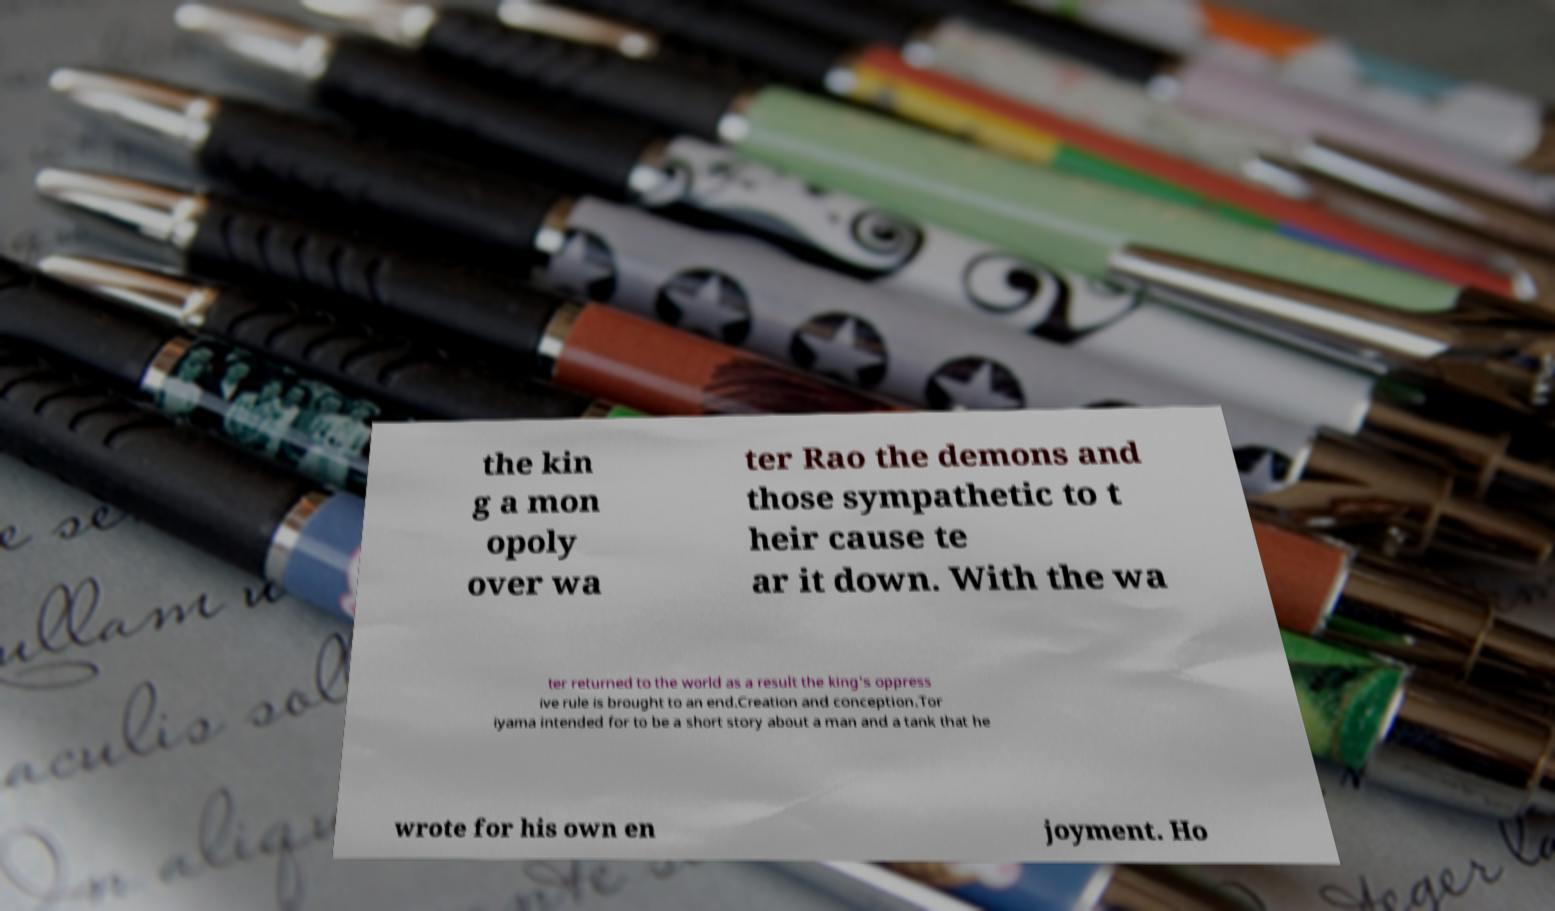Could you assist in decoding the text presented in this image and type it out clearly? the kin g a mon opoly over wa ter Rao the demons and those sympathetic to t heir cause te ar it down. With the wa ter returned to the world as a result the king's oppress ive rule is brought to an end.Creation and conception.Tor iyama intended for to be a short story about a man and a tank that he wrote for his own en joyment. Ho 